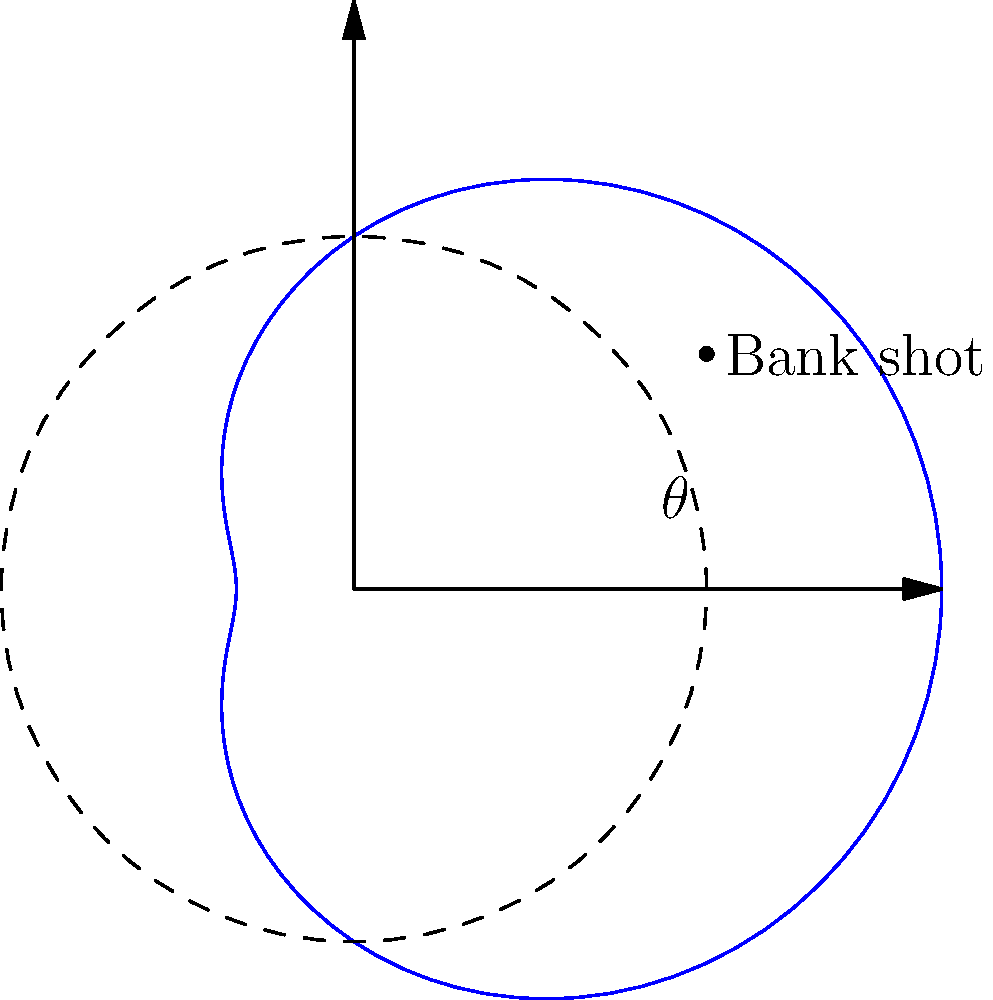In a crucial game against Michael Jordan, you're planning a bank shot. The basketball hoop's rim can be modeled by the polar equation $r = 3 + 2\cos(\theta)$. At what angle $\theta$ (in radians) should you aim to hit the rim at its closest point to the backboard? To find the angle where the rim is closest to the backboard, we need to follow these steps:

1) The distance from the center to any point on the rim is given by $r = 3 + 2\cos(\theta)$.

2) The backboard is represented by the line $\theta = 0$ or $\theta = 2\pi$ in polar coordinates.

3) To find the minimum distance, we need to find where $\frac{dr}{d\theta} = 0$:

   $\frac{dr}{d\theta} = -2\sin(\theta)$

4) Setting this equal to zero:
   $-2\sin(\theta) = 0$
   $\sin(\theta) = 0$

5) The solutions to this equation in the range $[0, 2\pi]$ are $\theta = 0, \pi, 2\pi$.

6) We need to check which of these gives the minimum $r$:

   At $\theta = 0$ or $2\pi$: $r = 3 + 2 = 5$
   At $\theta = \pi$: $r = 3 - 2 = 1$

7) The minimum distance occurs at $\theta = \pi$ radians.

Therefore, you should aim at an angle of $\pi$ radians to hit the rim at its closest point to the backboard.
Answer: $\pi$ radians 